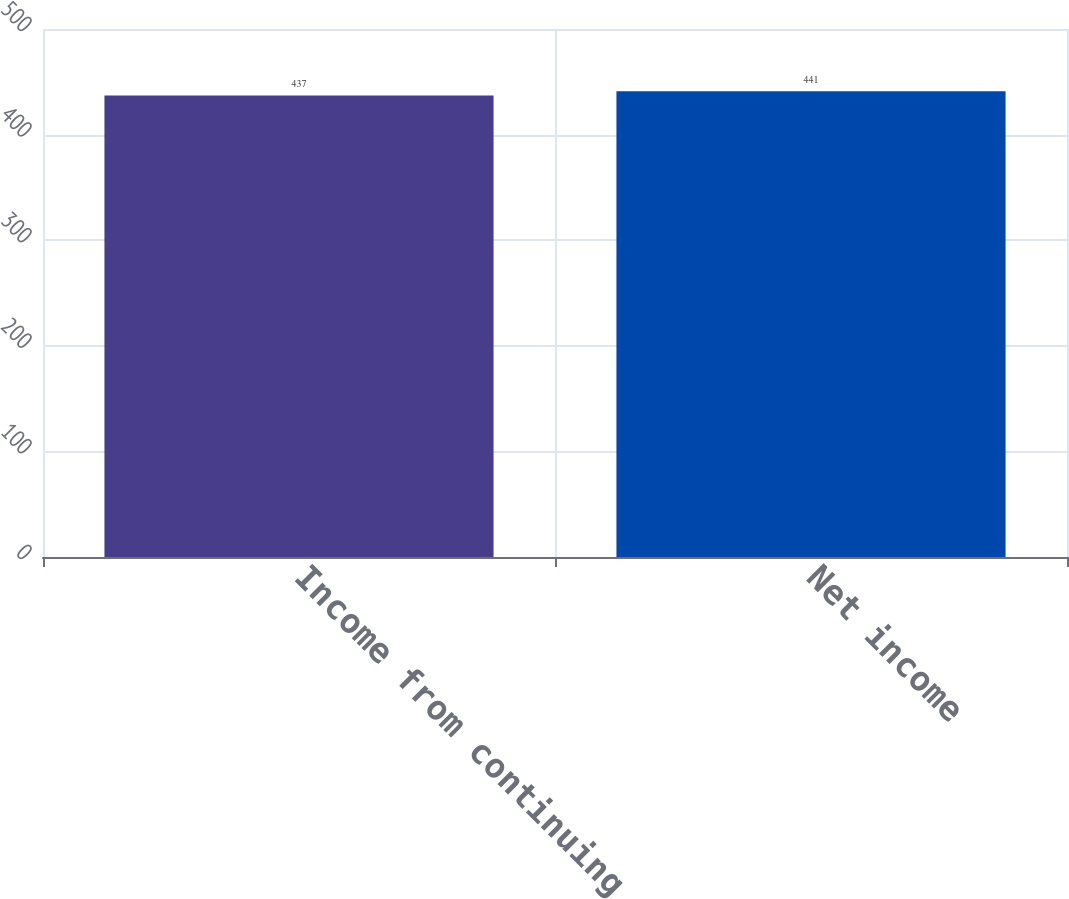Convert chart to OTSL. <chart><loc_0><loc_0><loc_500><loc_500><bar_chart><fcel>Income from continuing<fcel>Net income<nl><fcel>437<fcel>441<nl></chart> 